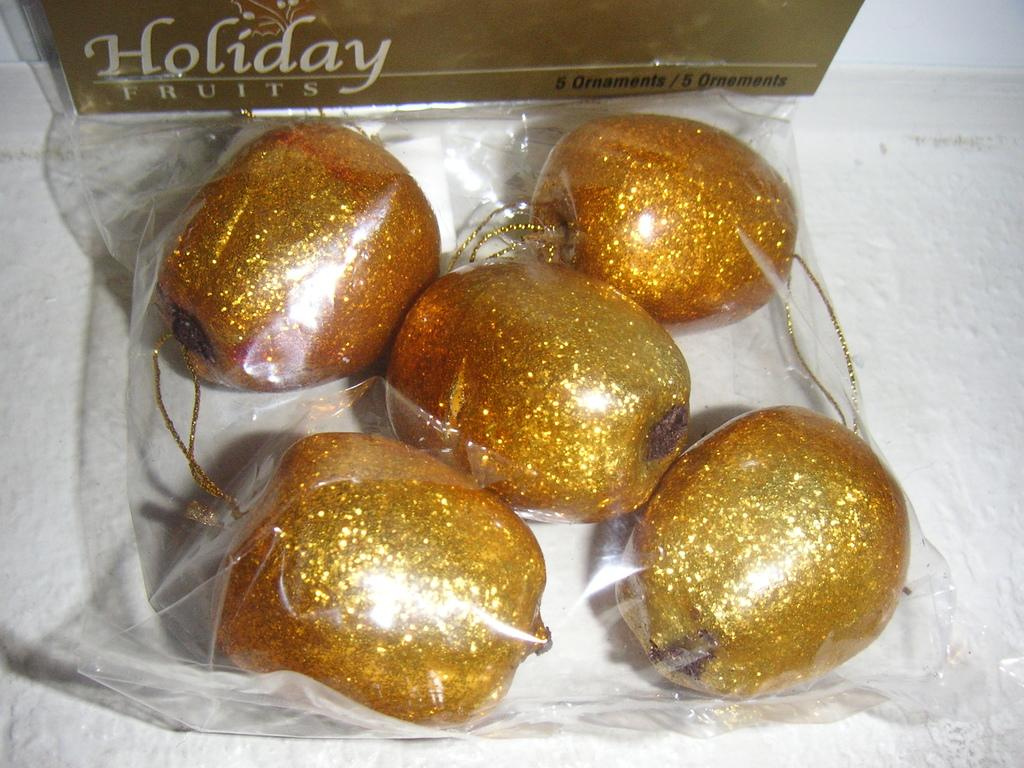What types of objects can be seen in the image? There are decorative items in the image. What is written or drawn on the paper in the image? There is text on a paper in the image. What color is the background of the image? The background of the image is white. How many sheep are visible in the image? There are no sheep present in the image. What is the condition of the chin of the person in the image? There is no person present in the image, so it is not possible to determine the condition of their chin. 